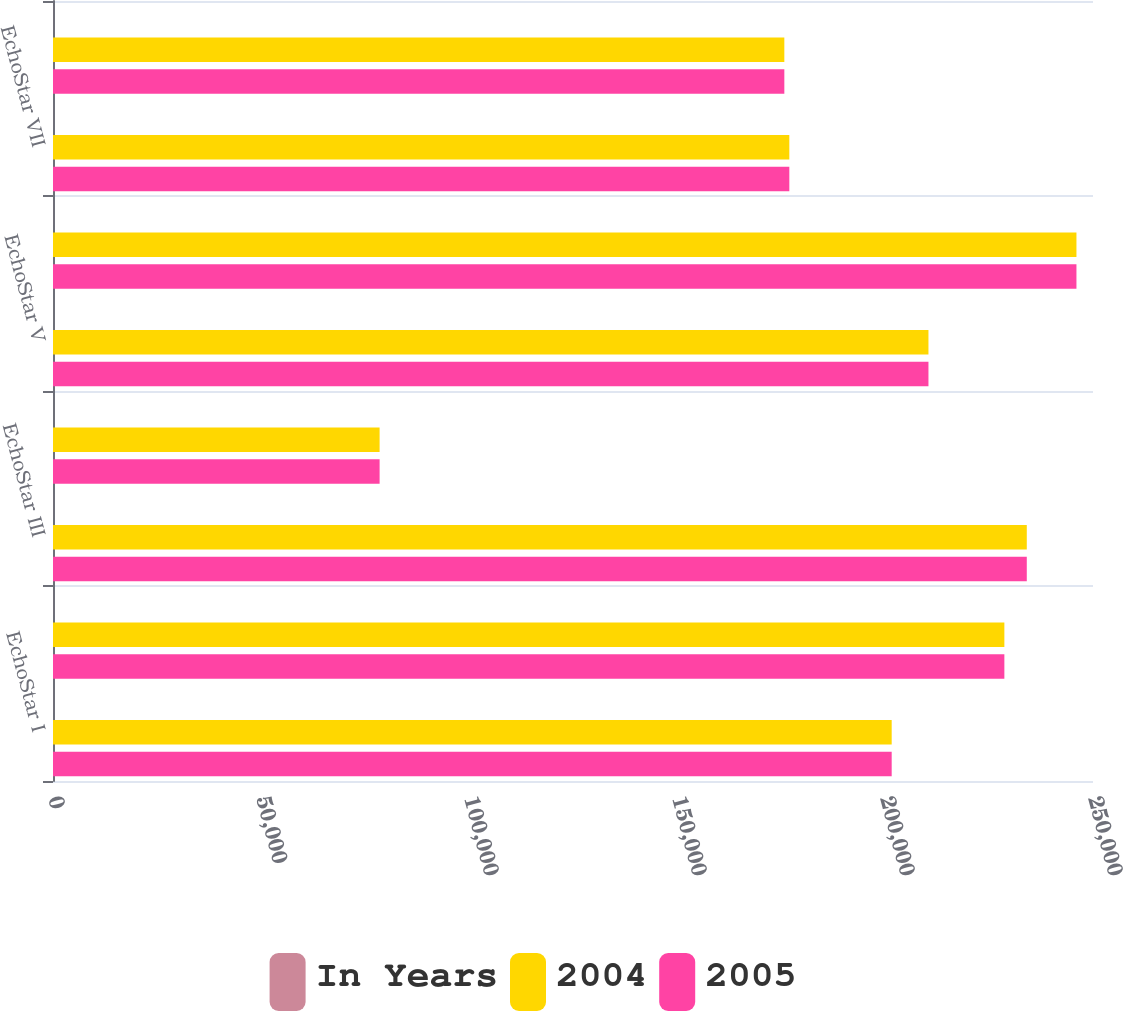Convert chart. <chart><loc_0><loc_0><loc_500><loc_500><stacked_bar_chart><ecel><fcel>EchoStar I<fcel>EchoStar II<fcel>EchoStar III<fcel>EchoStar IV - fully<fcel>EchoStar V<fcel>EchoStar VI<fcel>EchoStar VII<fcel>EchoStar VIII<nl><fcel>In Years<fcel>12<fcel>12<fcel>12<fcel>4<fcel>9<fcel>12<fcel>12<fcel>12<nl><fcel>2004<fcel>201607<fcel>228694<fcel>234083<fcel>78511<fcel>210446<fcel>246022<fcel>177000<fcel>175801<nl><fcel>2005<fcel>201607<fcel>228694<fcel>234083<fcel>78511<fcel>210446<fcel>246022<fcel>177000<fcel>175801<nl></chart> 